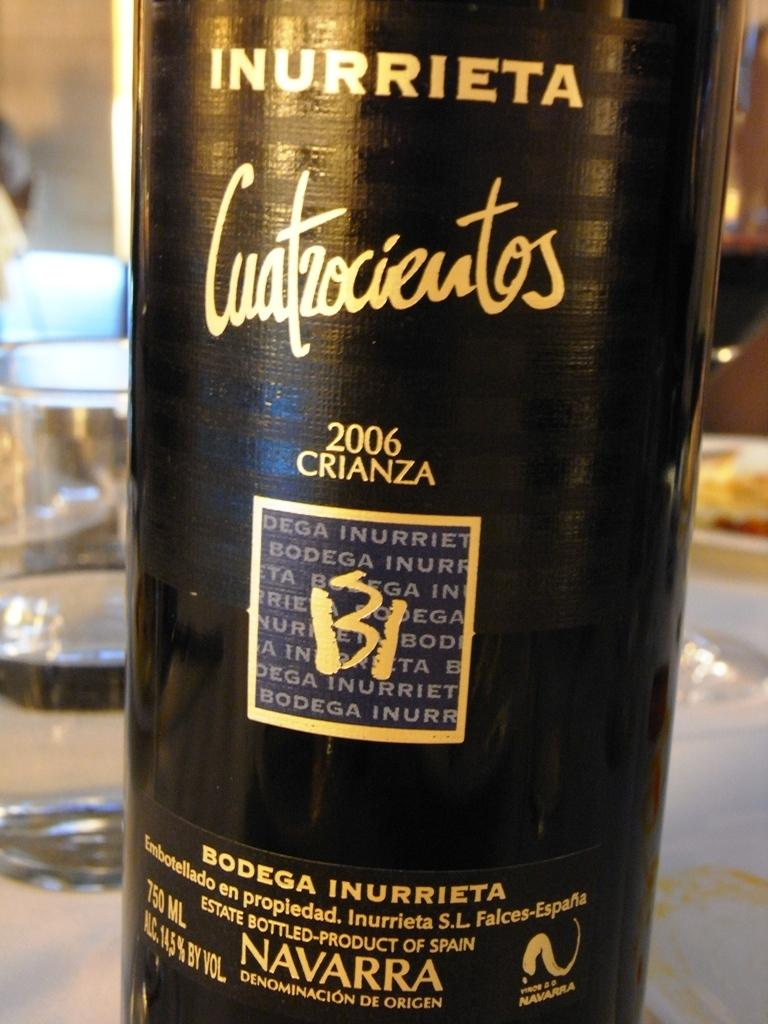<image>
Create a compact narrative representing the image presented. A wine bottle from the brand Bodega Inurrieta 